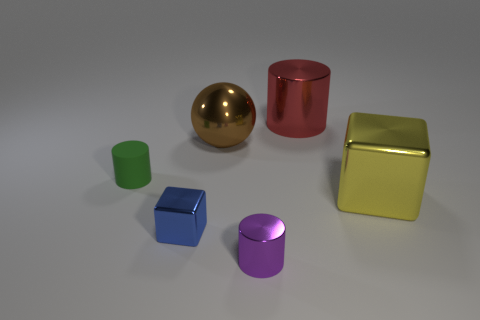Is the color of the small cube the same as the small cylinder behind the big cube?
Provide a short and direct response. No. Is the size of the red thing that is behind the purple thing the same as the blue shiny object?
Make the answer very short. No. There is a large thing that is the same shape as the tiny green object; what is its material?
Provide a short and direct response. Metal. Is the large red metal object the same shape as the large yellow object?
Give a very brief answer. No. How many purple objects are behind the sphere right of the green rubber object?
Your answer should be very brief. 0. What is the shape of the yellow thing that is the same material as the small blue block?
Make the answer very short. Cube. How many brown things are tiny rubber cubes or metallic objects?
Provide a succinct answer. 1. There is a small shiny thing behind the tiny cylinder that is on the right side of the blue metal thing; is there a big shiny block to the left of it?
Your answer should be very brief. No. Is the number of matte cylinders less than the number of large red blocks?
Give a very brief answer. No. There is a small object right of the small blue cube; is it the same shape as the big brown thing?
Your answer should be very brief. No. 